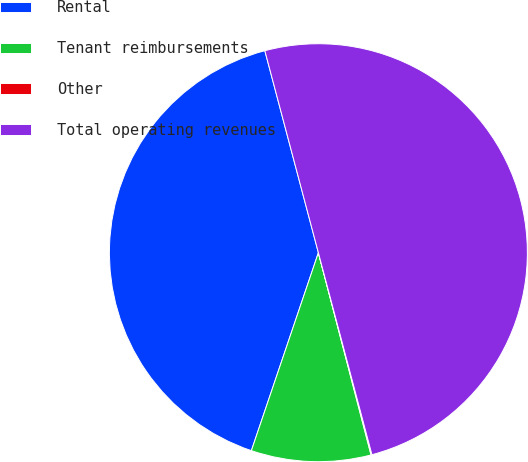Convert chart to OTSL. <chart><loc_0><loc_0><loc_500><loc_500><pie_chart><fcel>Rental<fcel>Tenant reimbursements<fcel>Other<fcel>Total operating revenues<nl><fcel>40.68%<fcel>9.25%<fcel>0.07%<fcel>50.0%<nl></chart> 